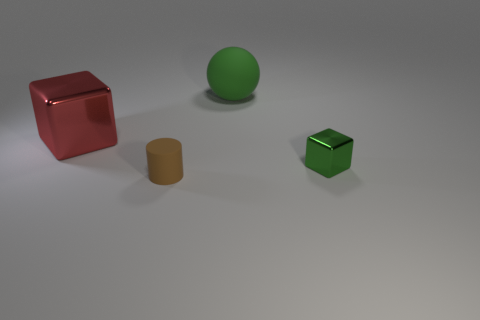Add 4 green blocks. How many objects exist? 8 Subtract all green cubes. How many cubes are left? 1 Subtract 1 cubes. How many cubes are left? 1 Subtract all purple cylinders. How many green blocks are left? 1 Subtract all tiny brown shiny balls. Subtract all green spheres. How many objects are left? 3 Add 1 big red objects. How many big red objects are left? 2 Add 1 big cyan metal things. How many big cyan metal things exist? 1 Subtract 0 gray cylinders. How many objects are left? 4 Subtract all spheres. How many objects are left? 3 Subtract all cyan cylinders. Subtract all brown spheres. How many cylinders are left? 1 